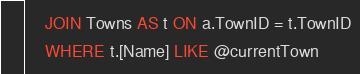<code> <loc_0><loc_0><loc_500><loc_500><_SQL_>	JOIN Towns AS t ON a.TownID = t.TownID
	WHERE t.[Name] LIKE @currentTown
</code> 